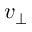Convert formula to latex. <formula><loc_0><loc_0><loc_500><loc_500>v _ { \perp }</formula> 